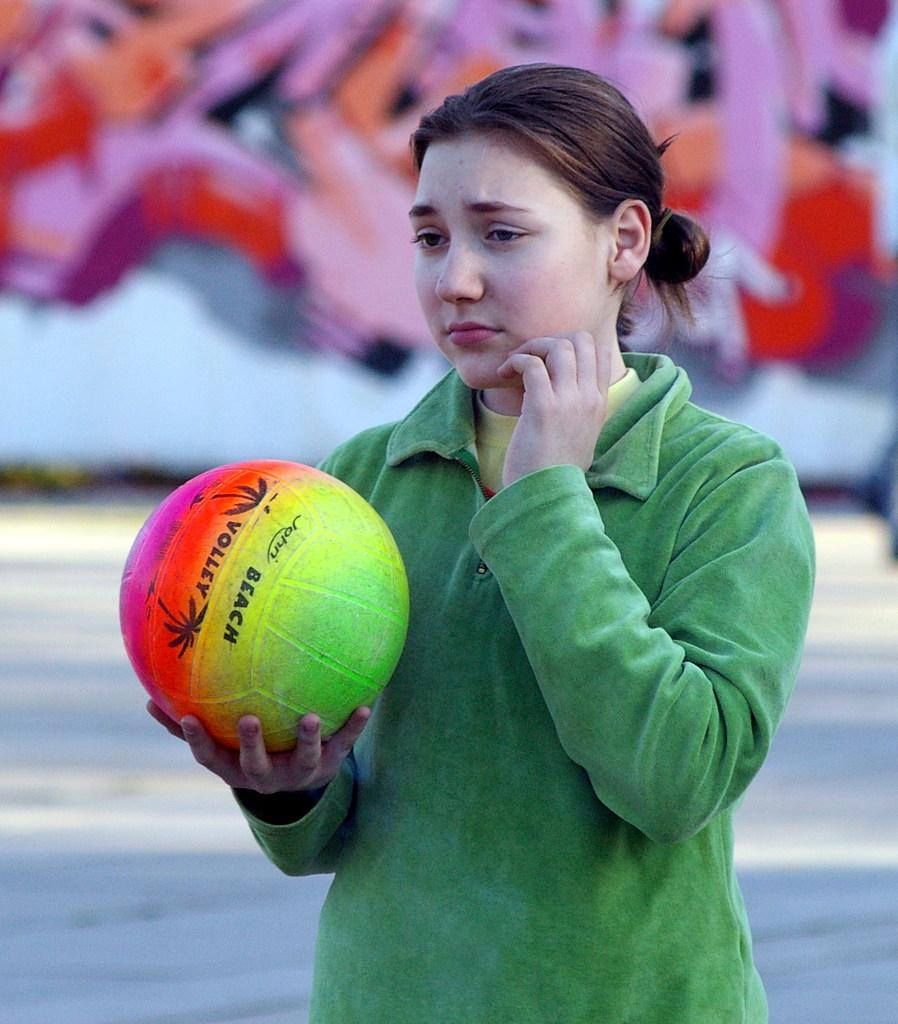What can be seen in the image? There is a person in the image. What is the person doing in the image? The person is holding an object. Can you describe the background of the image? The background of the image is blurred. What type of iron can be seen in the image? There is no iron present in the image. 